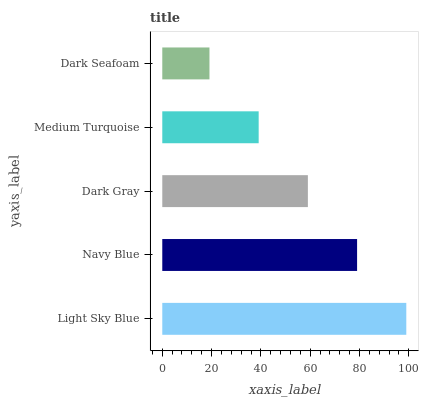Is Dark Seafoam the minimum?
Answer yes or no. Yes. Is Light Sky Blue the maximum?
Answer yes or no. Yes. Is Navy Blue the minimum?
Answer yes or no. No. Is Navy Blue the maximum?
Answer yes or no. No. Is Light Sky Blue greater than Navy Blue?
Answer yes or no. Yes. Is Navy Blue less than Light Sky Blue?
Answer yes or no. Yes. Is Navy Blue greater than Light Sky Blue?
Answer yes or no. No. Is Light Sky Blue less than Navy Blue?
Answer yes or no. No. Is Dark Gray the high median?
Answer yes or no. Yes. Is Dark Gray the low median?
Answer yes or no. Yes. Is Dark Seafoam the high median?
Answer yes or no. No. Is Navy Blue the low median?
Answer yes or no. No. 